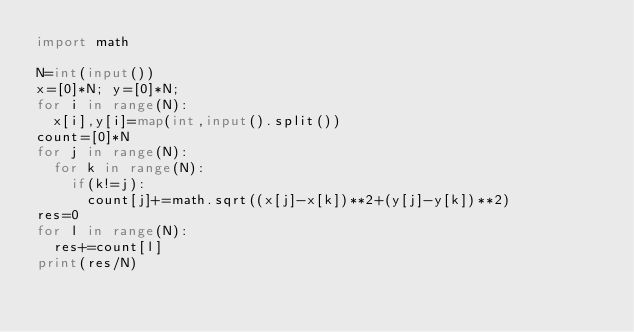Convert code to text. <code><loc_0><loc_0><loc_500><loc_500><_Python_>import math

N=int(input())
x=[0]*N; y=[0]*N;
for i in range(N):
  x[i],y[i]=map(int,input().split())
count=[0]*N
for j in range(N):
  for k in range(N):
    if(k!=j):
      count[j]+=math.sqrt((x[j]-x[k])**2+(y[j]-y[k])**2)
res=0
for l in range(N):
  res+=count[l]
print(res/N)</code> 